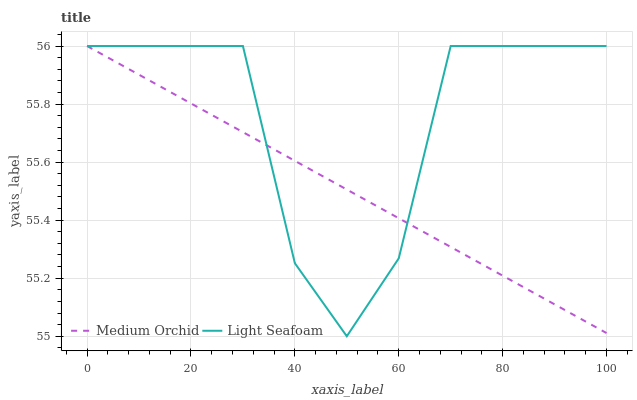Does Medium Orchid have the minimum area under the curve?
Answer yes or no. Yes. Does Light Seafoam have the maximum area under the curve?
Answer yes or no. Yes. Does Light Seafoam have the minimum area under the curve?
Answer yes or no. No. Is Medium Orchid the smoothest?
Answer yes or no. Yes. Is Light Seafoam the roughest?
Answer yes or no. Yes. Is Light Seafoam the smoothest?
Answer yes or no. No. 